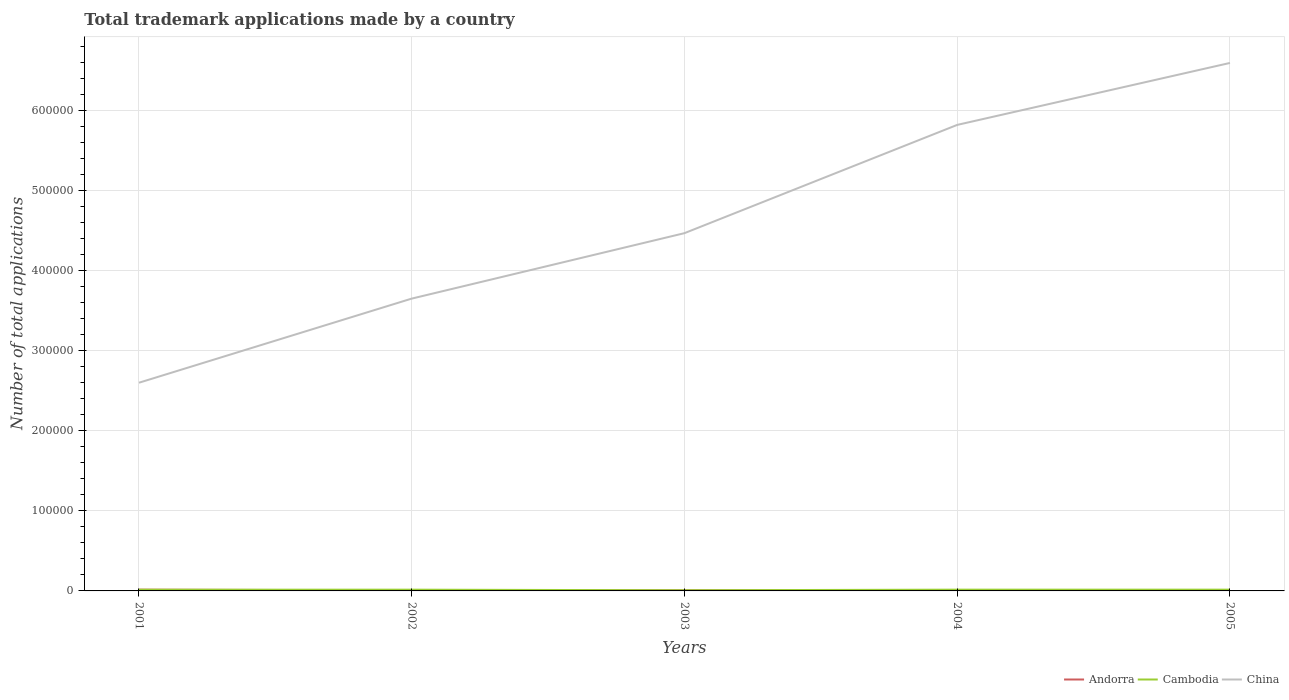How many different coloured lines are there?
Your answer should be very brief. 3. Across all years, what is the maximum number of applications made by in Andorra?
Make the answer very short. 725. What is the total number of applications made by in Andorra in the graph?
Give a very brief answer. -134. What is the difference between the highest and the second highest number of applications made by in Andorra?
Your response must be concise. 853. Is the number of applications made by in China strictly greater than the number of applications made by in Cambodia over the years?
Offer a terse response. No. How many lines are there?
Keep it short and to the point. 3. How many years are there in the graph?
Make the answer very short. 5. Are the values on the major ticks of Y-axis written in scientific E-notation?
Provide a short and direct response. No. Does the graph contain any zero values?
Your response must be concise. No. Does the graph contain grids?
Keep it short and to the point. Yes. How many legend labels are there?
Your response must be concise. 3. How are the legend labels stacked?
Your response must be concise. Horizontal. What is the title of the graph?
Your answer should be compact. Total trademark applications made by a country. What is the label or title of the X-axis?
Your answer should be compact. Years. What is the label or title of the Y-axis?
Make the answer very short. Number of total applications. What is the Number of total applications in Andorra in 2001?
Give a very brief answer. 1578. What is the Number of total applications of Cambodia in 2001?
Offer a very short reply. 1519. What is the Number of total applications of China in 2001?
Offer a terse response. 2.60e+05. What is the Number of total applications of Andorra in 2002?
Your answer should be compact. 725. What is the Number of total applications of Cambodia in 2002?
Keep it short and to the point. 1569. What is the Number of total applications of China in 2002?
Your answer should be very brief. 3.65e+05. What is the Number of total applications of Andorra in 2003?
Provide a succinct answer. 859. What is the Number of total applications of Cambodia in 2003?
Provide a succinct answer. 827. What is the Number of total applications in China in 2003?
Ensure brevity in your answer.  4.47e+05. What is the Number of total applications of Andorra in 2004?
Make the answer very short. 741. What is the Number of total applications of Cambodia in 2004?
Make the answer very short. 1577. What is the Number of total applications of China in 2004?
Make the answer very short. 5.82e+05. What is the Number of total applications in Andorra in 2005?
Your answer should be compact. 806. What is the Number of total applications in Cambodia in 2005?
Ensure brevity in your answer.  1581. What is the Number of total applications of China in 2005?
Give a very brief answer. 6.59e+05. Across all years, what is the maximum Number of total applications of Andorra?
Keep it short and to the point. 1578. Across all years, what is the maximum Number of total applications in Cambodia?
Offer a terse response. 1581. Across all years, what is the maximum Number of total applications of China?
Provide a short and direct response. 6.59e+05. Across all years, what is the minimum Number of total applications in Andorra?
Make the answer very short. 725. Across all years, what is the minimum Number of total applications in Cambodia?
Your answer should be very brief. 827. Across all years, what is the minimum Number of total applications in China?
Give a very brief answer. 2.60e+05. What is the total Number of total applications of Andorra in the graph?
Offer a terse response. 4709. What is the total Number of total applications of Cambodia in the graph?
Provide a short and direct response. 7073. What is the total Number of total applications of China in the graph?
Your response must be concise. 2.31e+06. What is the difference between the Number of total applications in Andorra in 2001 and that in 2002?
Give a very brief answer. 853. What is the difference between the Number of total applications in Cambodia in 2001 and that in 2002?
Provide a short and direct response. -50. What is the difference between the Number of total applications in China in 2001 and that in 2002?
Give a very brief answer. -1.05e+05. What is the difference between the Number of total applications of Andorra in 2001 and that in 2003?
Make the answer very short. 719. What is the difference between the Number of total applications of Cambodia in 2001 and that in 2003?
Provide a succinct answer. 692. What is the difference between the Number of total applications of China in 2001 and that in 2003?
Ensure brevity in your answer.  -1.87e+05. What is the difference between the Number of total applications of Andorra in 2001 and that in 2004?
Provide a succinct answer. 837. What is the difference between the Number of total applications of Cambodia in 2001 and that in 2004?
Keep it short and to the point. -58. What is the difference between the Number of total applications in China in 2001 and that in 2004?
Keep it short and to the point. -3.22e+05. What is the difference between the Number of total applications in Andorra in 2001 and that in 2005?
Your response must be concise. 772. What is the difference between the Number of total applications of Cambodia in 2001 and that in 2005?
Provide a short and direct response. -62. What is the difference between the Number of total applications in China in 2001 and that in 2005?
Your answer should be very brief. -3.99e+05. What is the difference between the Number of total applications in Andorra in 2002 and that in 2003?
Give a very brief answer. -134. What is the difference between the Number of total applications in Cambodia in 2002 and that in 2003?
Offer a very short reply. 742. What is the difference between the Number of total applications in China in 2002 and that in 2003?
Ensure brevity in your answer.  -8.17e+04. What is the difference between the Number of total applications of Andorra in 2002 and that in 2004?
Offer a very short reply. -16. What is the difference between the Number of total applications in Cambodia in 2002 and that in 2004?
Give a very brief answer. -8. What is the difference between the Number of total applications of China in 2002 and that in 2004?
Give a very brief answer. -2.17e+05. What is the difference between the Number of total applications in Andorra in 2002 and that in 2005?
Ensure brevity in your answer.  -81. What is the difference between the Number of total applications of Cambodia in 2002 and that in 2005?
Provide a short and direct response. -12. What is the difference between the Number of total applications in China in 2002 and that in 2005?
Provide a short and direct response. -2.94e+05. What is the difference between the Number of total applications in Andorra in 2003 and that in 2004?
Make the answer very short. 118. What is the difference between the Number of total applications of Cambodia in 2003 and that in 2004?
Ensure brevity in your answer.  -750. What is the difference between the Number of total applications in China in 2003 and that in 2004?
Your response must be concise. -1.35e+05. What is the difference between the Number of total applications in Cambodia in 2003 and that in 2005?
Provide a succinct answer. -754. What is the difference between the Number of total applications in China in 2003 and that in 2005?
Give a very brief answer. -2.12e+05. What is the difference between the Number of total applications in Andorra in 2004 and that in 2005?
Keep it short and to the point. -65. What is the difference between the Number of total applications in Cambodia in 2004 and that in 2005?
Ensure brevity in your answer.  -4. What is the difference between the Number of total applications in China in 2004 and that in 2005?
Your response must be concise. -7.73e+04. What is the difference between the Number of total applications in Andorra in 2001 and the Number of total applications in China in 2002?
Offer a terse response. -3.63e+05. What is the difference between the Number of total applications in Cambodia in 2001 and the Number of total applications in China in 2002?
Ensure brevity in your answer.  -3.63e+05. What is the difference between the Number of total applications in Andorra in 2001 and the Number of total applications in Cambodia in 2003?
Provide a short and direct response. 751. What is the difference between the Number of total applications of Andorra in 2001 and the Number of total applications of China in 2003?
Your answer should be compact. -4.45e+05. What is the difference between the Number of total applications in Cambodia in 2001 and the Number of total applications in China in 2003?
Make the answer very short. -4.45e+05. What is the difference between the Number of total applications of Andorra in 2001 and the Number of total applications of China in 2004?
Your answer should be compact. -5.80e+05. What is the difference between the Number of total applications in Cambodia in 2001 and the Number of total applications in China in 2004?
Give a very brief answer. -5.80e+05. What is the difference between the Number of total applications of Andorra in 2001 and the Number of total applications of China in 2005?
Your response must be concise. -6.58e+05. What is the difference between the Number of total applications in Cambodia in 2001 and the Number of total applications in China in 2005?
Your response must be concise. -6.58e+05. What is the difference between the Number of total applications of Andorra in 2002 and the Number of total applications of Cambodia in 2003?
Keep it short and to the point. -102. What is the difference between the Number of total applications of Andorra in 2002 and the Number of total applications of China in 2003?
Provide a succinct answer. -4.46e+05. What is the difference between the Number of total applications of Cambodia in 2002 and the Number of total applications of China in 2003?
Keep it short and to the point. -4.45e+05. What is the difference between the Number of total applications of Andorra in 2002 and the Number of total applications of Cambodia in 2004?
Offer a very short reply. -852. What is the difference between the Number of total applications of Andorra in 2002 and the Number of total applications of China in 2004?
Give a very brief answer. -5.81e+05. What is the difference between the Number of total applications of Cambodia in 2002 and the Number of total applications of China in 2004?
Offer a terse response. -5.80e+05. What is the difference between the Number of total applications in Andorra in 2002 and the Number of total applications in Cambodia in 2005?
Your answer should be very brief. -856. What is the difference between the Number of total applications of Andorra in 2002 and the Number of total applications of China in 2005?
Provide a short and direct response. -6.58e+05. What is the difference between the Number of total applications of Cambodia in 2002 and the Number of total applications of China in 2005?
Offer a very short reply. -6.58e+05. What is the difference between the Number of total applications in Andorra in 2003 and the Number of total applications in Cambodia in 2004?
Keep it short and to the point. -718. What is the difference between the Number of total applications of Andorra in 2003 and the Number of total applications of China in 2004?
Provide a succinct answer. -5.81e+05. What is the difference between the Number of total applications of Cambodia in 2003 and the Number of total applications of China in 2004?
Offer a terse response. -5.81e+05. What is the difference between the Number of total applications of Andorra in 2003 and the Number of total applications of Cambodia in 2005?
Your answer should be compact. -722. What is the difference between the Number of total applications of Andorra in 2003 and the Number of total applications of China in 2005?
Provide a short and direct response. -6.58e+05. What is the difference between the Number of total applications in Cambodia in 2003 and the Number of total applications in China in 2005?
Provide a short and direct response. -6.58e+05. What is the difference between the Number of total applications in Andorra in 2004 and the Number of total applications in Cambodia in 2005?
Offer a very short reply. -840. What is the difference between the Number of total applications of Andorra in 2004 and the Number of total applications of China in 2005?
Offer a very short reply. -6.58e+05. What is the difference between the Number of total applications of Cambodia in 2004 and the Number of total applications of China in 2005?
Offer a very short reply. -6.58e+05. What is the average Number of total applications in Andorra per year?
Your answer should be compact. 941.8. What is the average Number of total applications of Cambodia per year?
Give a very brief answer. 1414.6. What is the average Number of total applications in China per year?
Provide a short and direct response. 4.62e+05. In the year 2001, what is the difference between the Number of total applications in Andorra and Number of total applications in Cambodia?
Give a very brief answer. 59. In the year 2001, what is the difference between the Number of total applications of Andorra and Number of total applications of China?
Provide a short and direct response. -2.58e+05. In the year 2001, what is the difference between the Number of total applications of Cambodia and Number of total applications of China?
Your response must be concise. -2.58e+05. In the year 2002, what is the difference between the Number of total applications in Andorra and Number of total applications in Cambodia?
Provide a short and direct response. -844. In the year 2002, what is the difference between the Number of total applications in Andorra and Number of total applications in China?
Your answer should be very brief. -3.64e+05. In the year 2002, what is the difference between the Number of total applications in Cambodia and Number of total applications in China?
Your answer should be very brief. -3.63e+05. In the year 2003, what is the difference between the Number of total applications in Andorra and Number of total applications in Cambodia?
Your response must be concise. 32. In the year 2003, what is the difference between the Number of total applications of Andorra and Number of total applications of China?
Offer a terse response. -4.46e+05. In the year 2003, what is the difference between the Number of total applications of Cambodia and Number of total applications of China?
Give a very brief answer. -4.46e+05. In the year 2004, what is the difference between the Number of total applications of Andorra and Number of total applications of Cambodia?
Offer a very short reply. -836. In the year 2004, what is the difference between the Number of total applications of Andorra and Number of total applications of China?
Provide a succinct answer. -5.81e+05. In the year 2004, what is the difference between the Number of total applications of Cambodia and Number of total applications of China?
Provide a short and direct response. -5.80e+05. In the year 2005, what is the difference between the Number of total applications of Andorra and Number of total applications of Cambodia?
Offer a terse response. -775. In the year 2005, what is the difference between the Number of total applications of Andorra and Number of total applications of China?
Offer a terse response. -6.58e+05. In the year 2005, what is the difference between the Number of total applications of Cambodia and Number of total applications of China?
Provide a succinct answer. -6.58e+05. What is the ratio of the Number of total applications of Andorra in 2001 to that in 2002?
Make the answer very short. 2.18. What is the ratio of the Number of total applications in Cambodia in 2001 to that in 2002?
Your answer should be very brief. 0.97. What is the ratio of the Number of total applications of China in 2001 to that in 2002?
Provide a succinct answer. 0.71. What is the ratio of the Number of total applications of Andorra in 2001 to that in 2003?
Ensure brevity in your answer.  1.84. What is the ratio of the Number of total applications in Cambodia in 2001 to that in 2003?
Your answer should be compact. 1.84. What is the ratio of the Number of total applications in China in 2001 to that in 2003?
Give a very brief answer. 0.58. What is the ratio of the Number of total applications in Andorra in 2001 to that in 2004?
Provide a short and direct response. 2.13. What is the ratio of the Number of total applications in Cambodia in 2001 to that in 2004?
Provide a short and direct response. 0.96. What is the ratio of the Number of total applications of China in 2001 to that in 2004?
Ensure brevity in your answer.  0.45. What is the ratio of the Number of total applications of Andorra in 2001 to that in 2005?
Provide a succinct answer. 1.96. What is the ratio of the Number of total applications of Cambodia in 2001 to that in 2005?
Your answer should be very brief. 0.96. What is the ratio of the Number of total applications in China in 2001 to that in 2005?
Ensure brevity in your answer.  0.39. What is the ratio of the Number of total applications in Andorra in 2002 to that in 2003?
Your answer should be very brief. 0.84. What is the ratio of the Number of total applications of Cambodia in 2002 to that in 2003?
Keep it short and to the point. 1.9. What is the ratio of the Number of total applications of China in 2002 to that in 2003?
Ensure brevity in your answer.  0.82. What is the ratio of the Number of total applications in Andorra in 2002 to that in 2004?
Make the answer very short. 0.98. What is the ratio of the Number of total applications in China in 2002 to that in 2004?
Your answer should be very brief. 0.63. What is the ratio of the Number of total applications in Andorra in 2002 to that in 2005?
Offer a very short reply. 0.9. What is the ratio of the Number of total applications in China in 2002 to that in 2005?
Offer a terse response. 0.55. What is the ratio of the Number of total applications of Andorra in 2003 to that in 2004?
Make the answer very short. 1.16. What is the ratio of the Number of total applications of Cambodia in 2003 to that in 2004?
Offer a very short reply. 0.52. What is the ratio of the Number of total applications in China in 2003 to that in 2004?
Ensure brevity in your answer.  0.77. What is the ratio of the Number of total applications of Andorra in 2003 to that in 2005?
Your answer should be compact. 1.07. What is the ratio of the Number of total applications in Cambodia in 2003 to that in 2005?
Provide a succinct answer. 0.52. What is the ratio of the Number of total applications in China in 2003 to that in 2005?
Your answer should be compact. 0.68. What is the ratio of the Number of total applications in Andorra in 2004 to that in 2005?
Give a very brief answer. 0.92. What is the ratio of the Number of total applications in China in 2004 to that in 2005?
Provide a short and direct response. 0.88. What is the difference between the highest and the second highest Number of total applications of Andorra?
Provide a short and direct response. 719. What is the difference between the highest and the second highest Number of total applications of Cambodia?
Your response must be concise. 4. What is the difference between the highest and the second highest Number of total applications in China?
Your answer should be compact. 7.73e+04. What is the difference between the highest and the lowest Number of total applications in Andorra?
Provide a succinct answer. 853. What is the difference between the highest and the lowest Number of total applications of Cambodia?
Give a very brief answer. 754. What is the difference between the highest and the lowest Number of total applications in China?
Make the answer very short. 3.99e+05. 